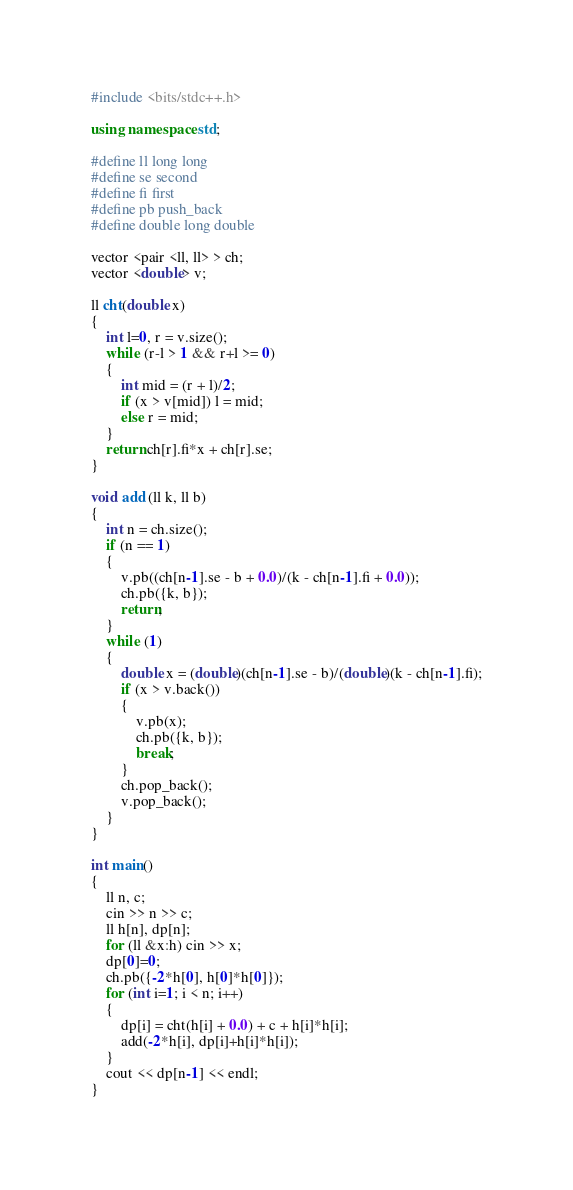Convert code to text. <code><loc_0><loc_0><loc_500><loc_500><_C++_>#include <bits/stdc++.h>
 
using namespace std;
 
#define ll long long
#define se second
#define fi first
#define pb push_back
#define double long double

vector <pair <ll, ll> > ch;
vector <double> v;

ll cht(double x)
{
    int l=0, r = v.size();
    while (r-l > 1 && r+l >= 0)
    {
        int mid = (r + l)/2;
        if (x > v[mid]) l = mid;
        else r = mid;
    }
    return ch[r].fi*x + ch[r].se;
}

void add (ll k, ll b)
{
    int n = ch.size();
    if (n == 1)
    {
        v.pb((ch[n-1].se - b + 0.0)/(k - ch[n-1].fi + 0.0));
        ch.pb({k, b});
        return;
    }
    while (1)
    {
        double x = (double)(ch[n-1].se - b)/(double)(k - ch[n-1].fi);
        if (x > v.back()) 
        {
            v.pb(x);
            ch.pb({k, b});
            break;
        }
        ch.pop_back();
        v.pop_back();
    }
}

int main()
{
    ll n, c;
    cin >> n >> c;
    ll h[n], dp[n];
    for (ll &x:h) cin >> x;
    dp[0]=0;
    ch.pb({-2*h[0], h[0]*h[0]});
    for (int i=1; i < n; i++)
    {
        dp[i] = cht(h[i] + 0.0) + c + h[i]*h[i];
        add(-2*h[i], dp[i]+h[i]*h[i]);
    }
    cout << dp[n-1] << endl;
}</code> 